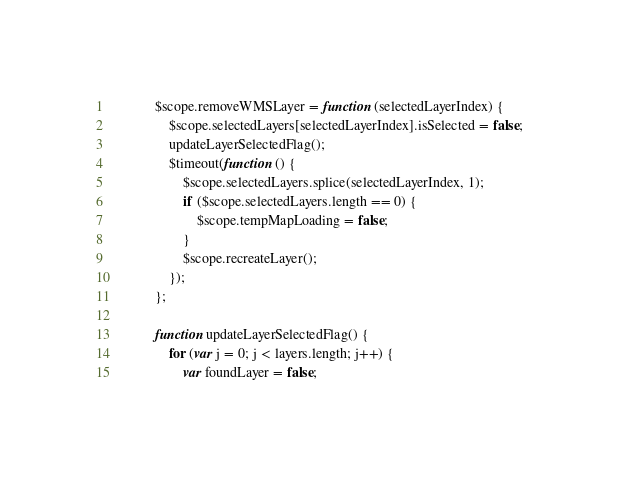Convert code to text. <code><loc_0><loc_0><loc_500><loc_500><_JavaScript_>
            $scope.removeWMSLayer = function (selectedLayerIndex) {
                $scope.selectedLayers[selectedLayerIndex].isSelected = false;
                updateLayerSelectedFlag();
                $timeout(function () {
                    $scope.selectedLayers.splice(selectedLayerIndex, 1);
                    if ($scope.selectedLayers.length == 0) {
                        $scope.tempMapLoading = false;
                    }
                    $scope.recreateLayer();
                });
            };

            function updateLayerSelectedFlag() {
                for (var j = 0; j < layers.length; j++) {
                    var foundLayer = false;</code> 